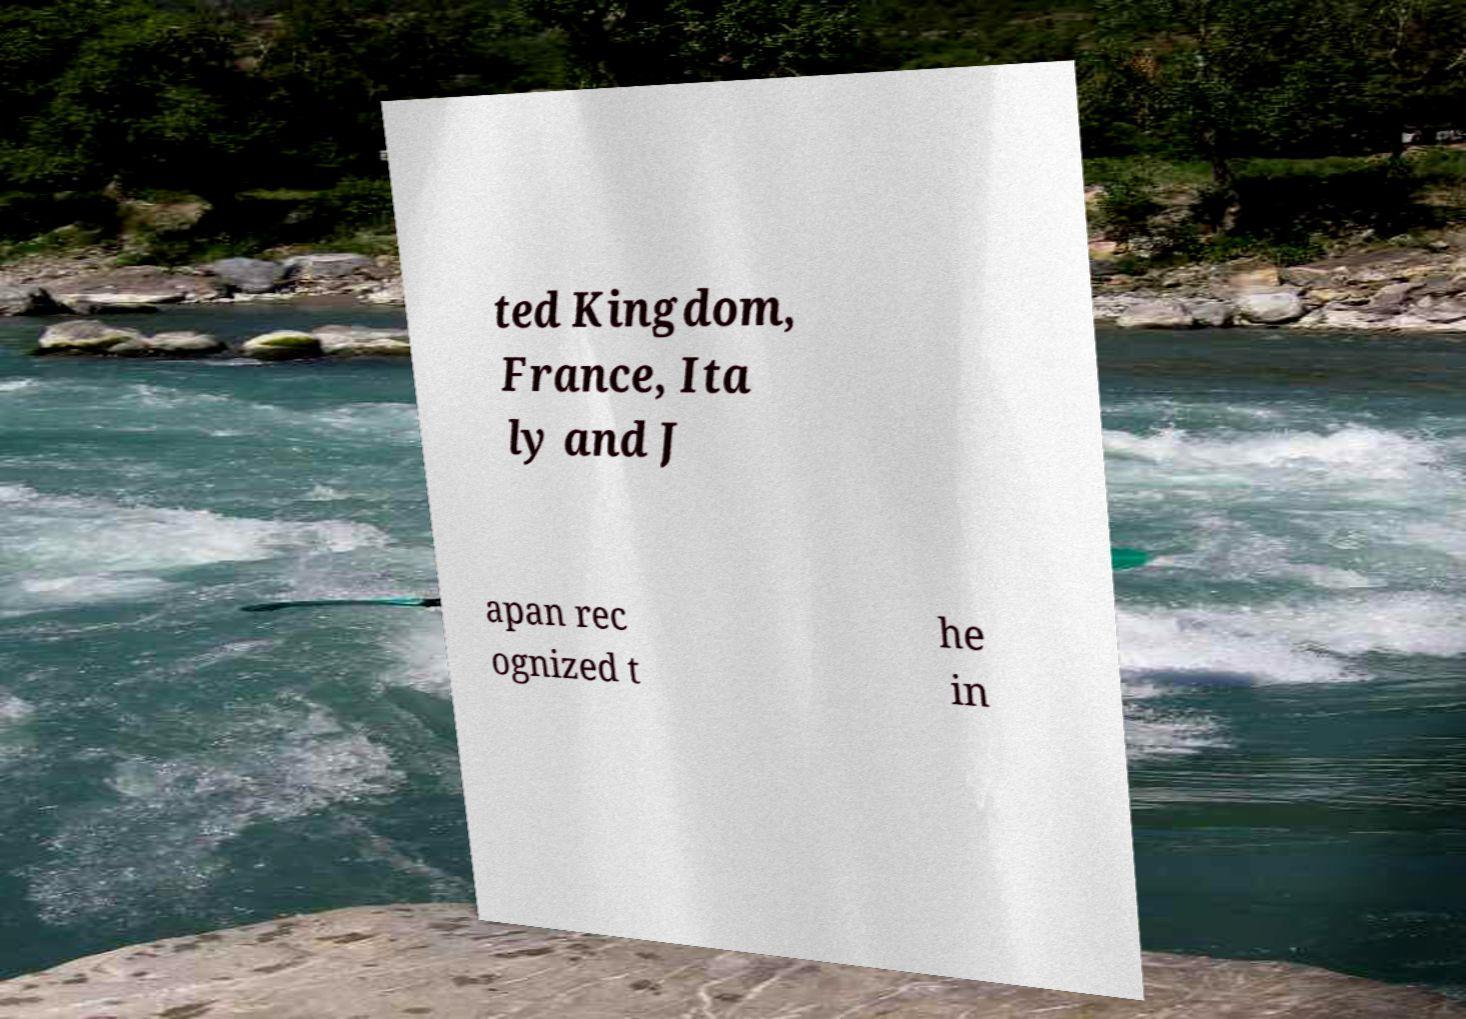What messages or text are displayed in this image? I need them in a readable, typed format. ted Kingdom, France, Ita ly and J apan rec ognized t he in 